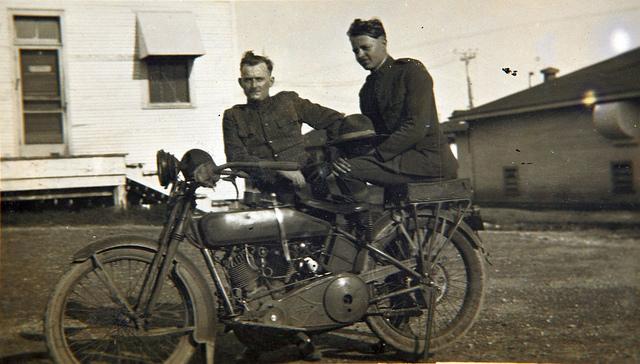Is this a modern photo?
Concise answer only. No. What is the man sitting on?
Give a very brief answer. Motorcycle. How many bikes are there?
Keep it brief. 1. Is this a public place?
Give a very brief answer. Yes. What is sitting on the bike seat?
Short answer required. Man. Is this around the World War II time?
Concise answer only. Yes. How many people in this photo have long hair?
Give a very brief answer. 0. Is the white bike locked to the pole?
Short answer required. No. How many people are standing around?
Give a very brief answer. 2. What are these men called?
Keep it brief. Soldiers. Is there a houseboat on the river?
Answer briefly. No. What do the half circle metal tire coverings prevent?
Be succinct. Dirt. Is he going to ride the bike?
Give a very brief answer. Yes. How many seats are on this bike?
Answer briefly. 1. How many different types of vehicles are shown?
Concise answer only. 1. Have these bicycles been modified to include motor?
Short answer required. Yes. What is on the ground?
Write a very short answer. Motorcycle. What brand is the bike?
Quick response, please. Harley. 